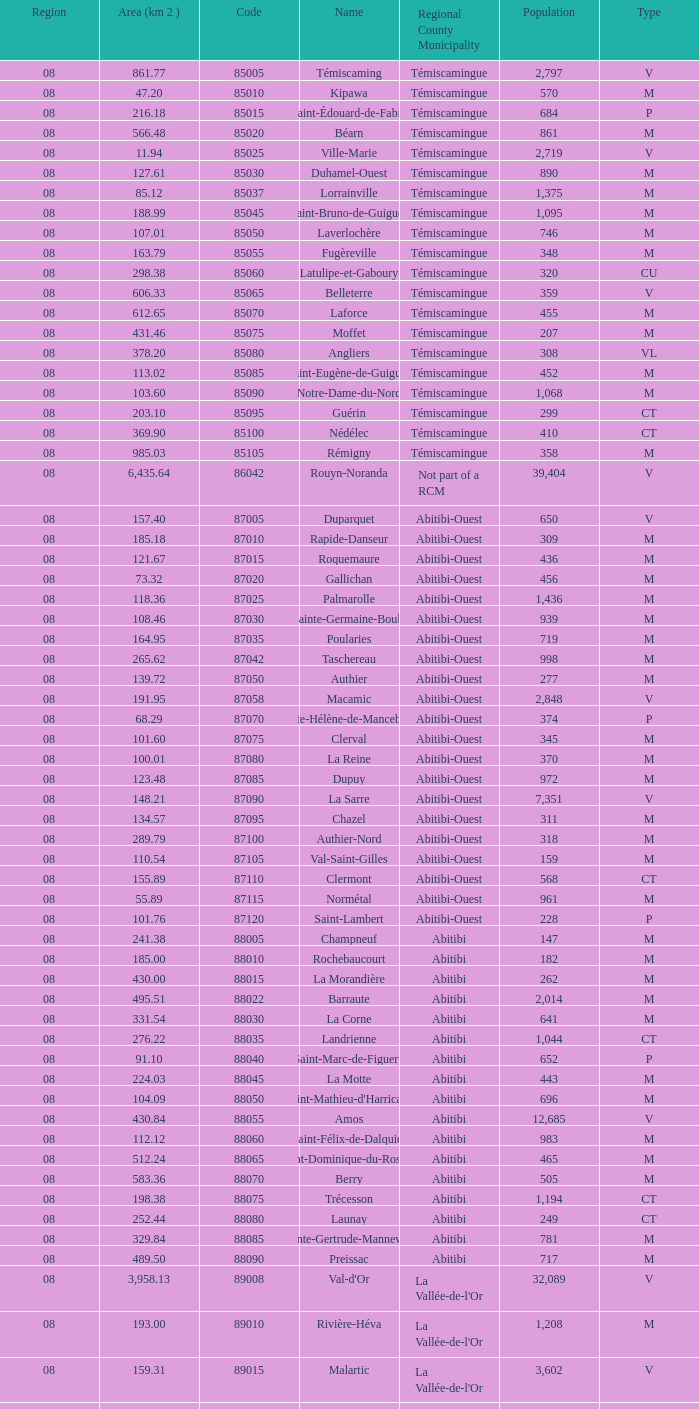I'm looking to parse the entire table for insights. Could you assist me with that? {'header': ['Region', 'Area (km 2 )', 'Code', 'Name', 'Regional County Municipality', 'Population', 'Type'], 'rows': [['08', '861.77', '85005', 'Témiscaming', 'Témiscamingue', '2,797', 'V'], ['08', '47.20', '85010', 'Kipawa', 'Témiscamingue', '570', 'M'], ['08', '216.18', '85015', 'Saint-Édouard-de-Fabre', 'Témiscamingue', '684', 'P'], ['08', '566.48', '85020', 'Béarn', 'Témiscamingue', '861', 'M'], ['08', '11.94', '85025', 'Ville-Marie', 'Témiscamingue', '2,719', 'V'], ['08', '127.61', '85030', 'Duhamel-Ouest', 'Témiscamingue', '890', 'M'], ['08', '85.12', '85037', 'Lorrainville', 'Témiscamingue', '1,375', 'M'], ['08', '188.99', '85045', 'Saint-Bruno-de-Guigues', 'Témiscamingue', '1,095', 'M'], ['08', '107.01', '85050', 'Laverlochère', 'Témiscamingue', '746', 'M'], ['08', '163.79', '85055', 'Fugèreville', 'Témiscamingue', '348', 'M'], ['08', '298.38', '85060', 'Latulipe-et-Gaboury', 'Témiscamingue', '320', 'CU'], ['08', '606.33', '85065', 'Belleterre', 'Témiscamingue', '359', 'V'], ['08', '612.65', '85070', 'Laforce', 'Témiscamingue', '455', 'M'], ['08', '431.46', '85075', 'Moffet', 'Témiscamingue', '207', 'M'], ['08', '378.20', '85080', 'Angliers', 'Témiscamingue', '308', 'VL'], ['08', '113.02', '85085', 'Saint-Eugène-de-Guigues', 'Témiscamingue', '452', 'M'], ['08', '103.60', '85090', 'Notre-Dame-du-Nord', 'Témiscamingue', '1,068', 'M'], ['08', '203.10', '85095', 'Guérin', 'Témiscamingue', '299', 'CT'], ['08', '369.90', '85100', 'Nédélec', 'Témiscamingue', '410', 'CT'], ['08', '985.03', '85105', 'Rémigny', 'Témiscamingue', '358', 'M'], ['08', '6,435.64', '86042', 'Rouyn-Noranda', 'Not part of a RCM', '39,404', 'V'], ['08', '157.40', '87005', 'Duparquet', 'Abitibi-Ouest', '650', 'V'], ['08', '185.18', '87010', 'Rapide-Danseur', 'Abitibi-Ouest', '309', 'M'], ['08', '121.67', '87015', 'Roquemaure', 'Abitibi-Ouest', '436', 'M'], ['08', '73.32', '87020', 'Gallichan', 'Abitibi-Ouest', '456', 'M'], ['08', '118.36', '87025', 'Palmarolle', 'Abitibi-Ouest', '1,436', 'M'], ['08', '108.46', '87030', 'Sainte-Germaine-Boulé', 'Abitibi-Ouest', '939', 'M'], ['08', '164.95', '87035', 'Poularies', 'Abitibi-Ouest', '719', 'M'], ['08', '265.62', '87042', 'Taschereau', 'Abitibi-Ouest', '998', 'M'], ['08', '139.72', '87050', 'Authier', 'Abitibi-Ouest', '277', 'M'], ['08', '191.95', '87058', 'Macamic', 'Abitibi-Ouest', '2,848', 'V'], ['08', '68.29', '87070', 'Sainte-Hélène-de-Mancebourg', 'Abitibi-Ouest', '374', 'P'], ['08', '101.60', '87075', 'Clerval', 'Abitibi-Ouest', '345', 'M'], ['08', '100.01', '87080', 'La Reine', 'Abitibi-Ouest', '370', 'M'], ['08', '123.48', '87085', 'Dupuy', 'Abitibi-Ouest', '972', 'M'], ['08', '148.21', '87090', 'La Sarre', 'Abitibi-Ouest', '7,351', 'V'], ['08', '134.57', '87095', 'Chazel', 'Abitibi-Ouest', '311', 'M'], ['08', '289.79', '87100', 'Authier-Nord', 'Abitibi-Ouest', '318', 'M'], ['08', '110.54', '87105', 'Val-Saint-Gilles', 'Abitibi-Ouest', '159', 'M'], ['08', '155.89', '87110', 'Clermont', 'Abitibi-Ouest', '568', 'CT'], ['08', '55.89', '87115', 'Normétal', 'Abitibi-Ouest', '961', 'M'], ['08', '101.76', '87120', 'Saint-Lambert', 'Abitibi-Ouest', '228', 'P'], ['08', '241.38', '88005', 'Champneuf', 'Abitibi', '147', 'M'], ['08', '185.00', '88010', 'Rochebaucourt', 'Abitibi', '182', 'M'], ['08', '430.00', '88015', 'La Morandière', 'Abitibi', '262', 'M'], ['08', '495.51', '88022', 'Barraute', 'Abitibi', '2,014', 'M'], ['08', '331.54', '88030', 'La Corne', 'Abitibi', '641', 'M'], ['08', '276.22', '88035', 'Landrienne', 'Abitibi', '1,044', 'CT'], ['08', '91.10', '88040', 'Saint-Marc-de-Figuery', 'Abitibi', '652', 'P'], ['08', '224.03', '88045', 'La Motte', 'Abitibi', '443', 'M'], ['08', '104.09', '88050', "Saint-Mathieu-d'Harricana", 'Abitibi', '696', 'M'], ['08', '430.84', '88055', 'Amos', 'Abitibi', '12,685', 'V'], ['08', '112.12', '88060', 'Saint-Félix-de-Dalquier', 'Abitibi', '983', 'M'], ['08', '512.24', '88065', 'Saint-Dominique-du-Rosaire', 'Abitibi', '465', 'M'], ['08', '583.36', '88070', 'Berry', 'Abitibi', '505', 'M'], ['08', '198.38', '88075', 'Trécesson', 'Abitibi', '1,194', 'CT'], ['08', '252.44', '88080', 'Launay', 'Abitibi', '249', 'CT'], ['08', '329.84', '88085', 'Sainte-Gertrude-Manneville', 'Abitibi', '781', 'M'], ['08', '489.50', '88090', 'Preissac', 'Abitibi', '717', 'M'], ['08', '3,958.13', '89008', "Val-d'Or", "La Vallée-de-l'Or", '32,089', 'V'], ['08', '193.00', '89010', 'Rivière-Héva', "La Vallée-de-l'Or", '1,208', 'M'], ['08', '159.31', '89015', 'Malartic', "La Vallée-de-l'Or", '3,602', 'V'], ['08', '16,524.89', '89040', 'Senneterre', "La Vallée-de-l'Or", '3,165', 'V'], ['08', '432.98', '89045', 'Senneterre', "La Vallée-de-l'Or", '1,146', 'P'], ['08', '411.23', '89050', 'Belcourt', "La Vallée-de-l'Or", '261', 'M']]} What is the km2 area for the population of 311? 134.57. 